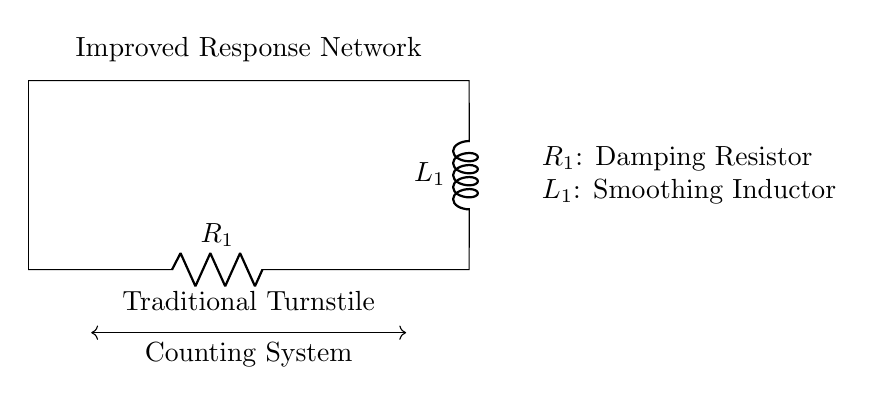What components are in the circuit? The circuit contains a resistor and an inductor, identified as R1 and L1 respectively.
Answer: Resistor, Inductor What is the role of R1 in the circuit? R1 acts as a damping resistor, which helps to control the response time and stability of the circuit in a turnstile counting system.
Answer: Damping Resistor What does L1 represent? L1 represents a smoothing inductor, which aids in reducing fluctuations in current and enhances the stability of the counting system's response.
Answer: Smoothing Inductor What is the function of the connection between R1 and L1? The connection between R1 and L1 allows for the resistor to influence the behavior of the inductor, enabling combined effects on the circuit's response to inputs.
Answer: Influence response How does adding the inductor affect the counting system? Adding the inductor helps to smooth out current variations, leading to a more stable counting operation by reducing noise and delay in response.
Answer: Smoother response Explain why a resistor is used in this type of circuit. A resistor is used to dampen any overshoot in current response caused by the inductor, thereby preventing erratic counting and improving reliability.
Answer: Prevent erratic counting What type of network is represented here? This is a resistor-inductor network specifically designed for improving the response in traditional turnstile counting systems.
Answer: Resistor-Inductor Network 